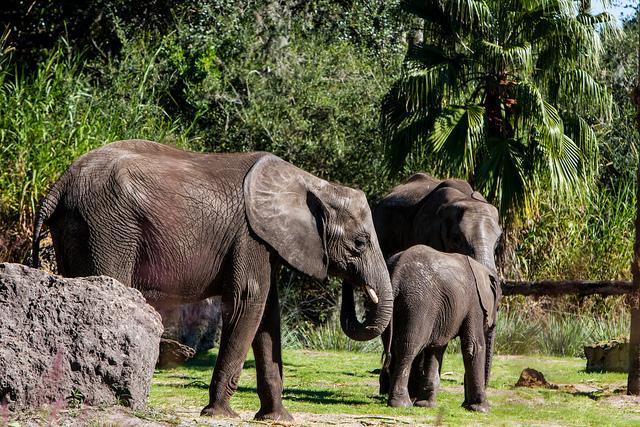Where is the baby elephant?
Short answer required. Middle. Are the elephants eating?
Answer briefly. No. Is that a coconut tree in the background?
Short answer required. Yes. How many baby elephants are in the picture?
Be succinct. 1. 